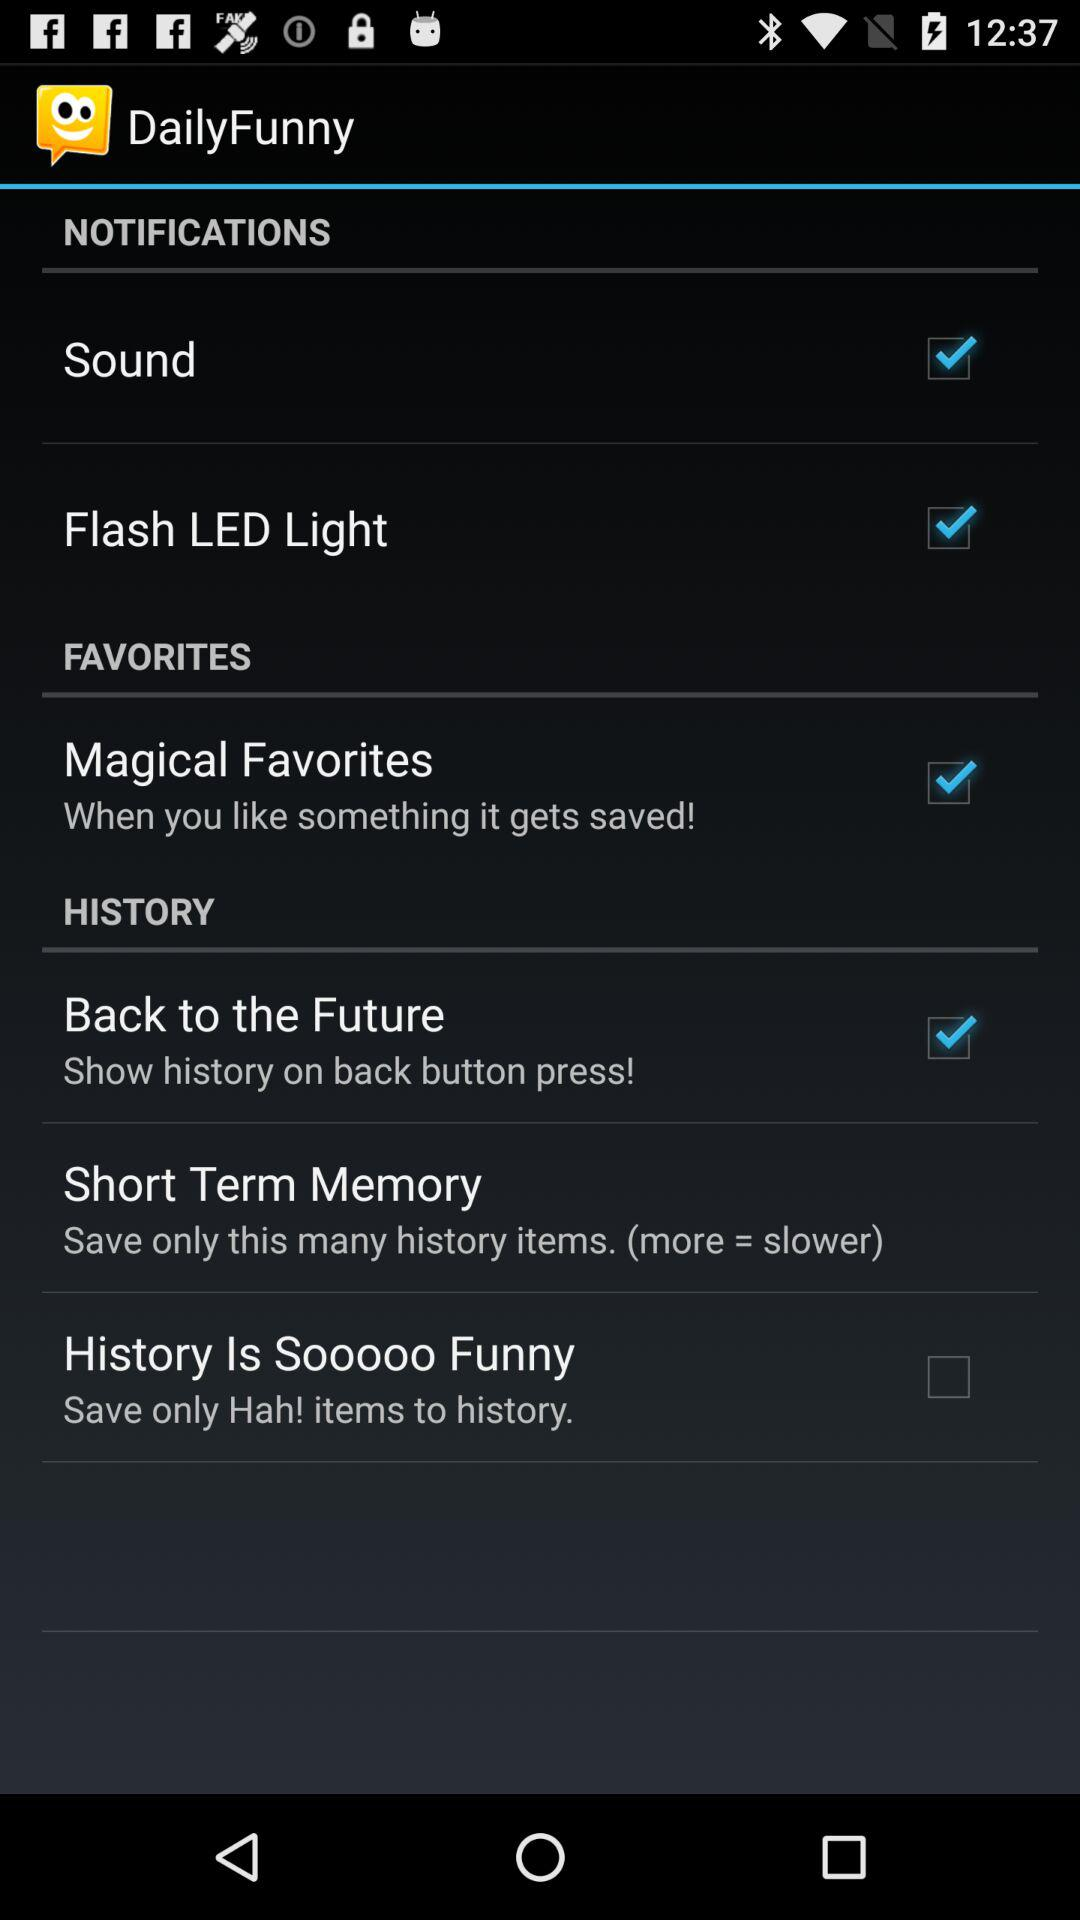What is the status of the "Flash LED Light"? The status is "on". 